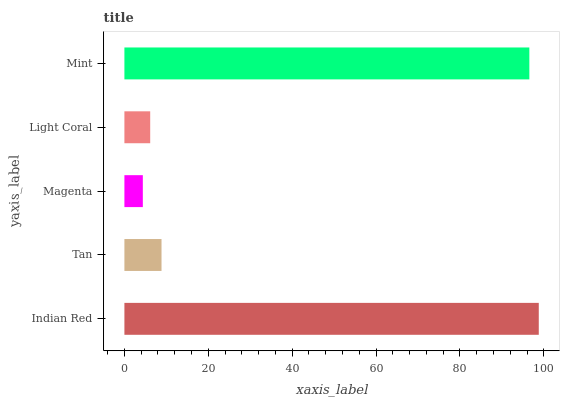Is Magenta the minimum?
Answer yes or no. Yes. Is Indian Red the maximum?
Answer yes or no. Yes. Is Tan the minimum?
Answer yes or no. No. Is Tan the maximum?
Answer yes or no. No. Is Indian Red greater than Tan?
Answer yes or no. Yes. Is Tan less than Indian Red?
Answer yes or no. Yes. Is Tan greater than Indian Red?
Answer yes or no. No. Is Indian Red less than Tan?
Answer yes or no. No. Is Tan the high median?
Answer yes or no. Yes. Is Tan the low median?
Answer yes or no. Yes. Is Indian Red the high median?
Answer yes or no. No. Is Indian Red the low median?
Answer yes or no. No. 